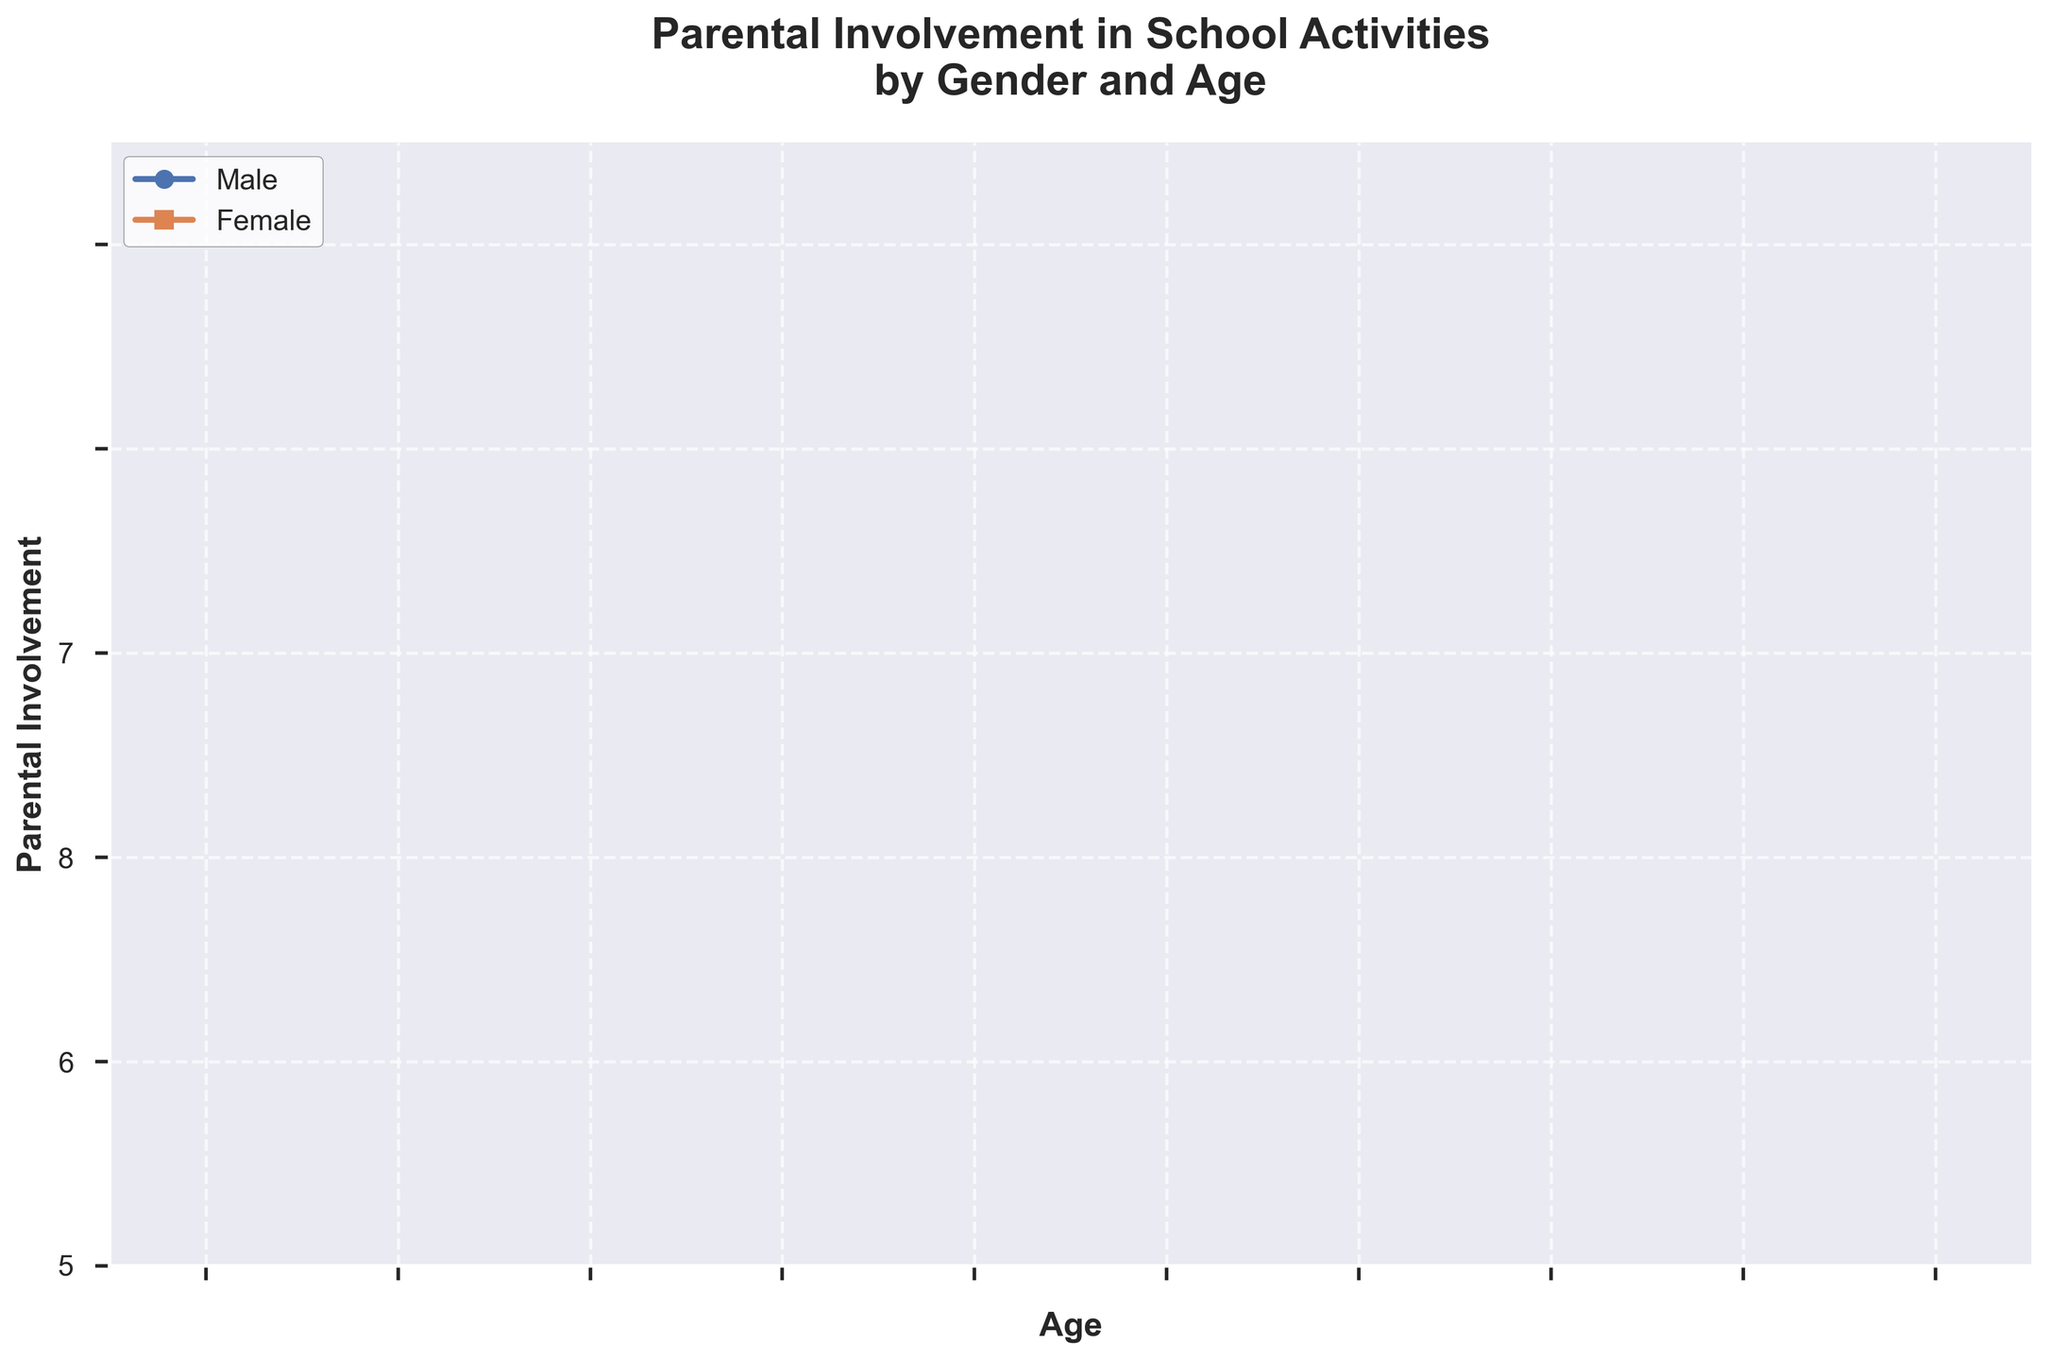What is the title of the plot? The title of the plot is displayed at the top of the figure in a larger, bold font, stating the focus of the data comparison.
Answer: Parental Involvement in School Activities by Gender and Age What age has the highest involvement for females? By looking at the stair plot for females (represented by a step line with square markers), identify the age with the maximum y-value.
Answer: 34 and 39 At what age do males have the minimum involvement? Examine the lowest point on the male stair plot (step line with circular markers) and note the corresponding age on the x-axis.
Answer: 34 On average, who has higher parental involvement, males or females? First, sum up the involvement values for both genders separately. Then divide each sum by the number of data points (10). Compare the two averages. For males: (5+4+6+5+3+4+5+4+6+4)/10=4.6. For females: (8+9+7+8+10+9+9+9+8+10)/10=8.7.
Answer: Females Which gender shows more fluctuations in involvement across ages? Examine the variability of the step lines for both genders on the plot. Fluctuations are indicated by the number and magnitude of changes in involvement values from one age to the next.
Answer: Females Does any age have equal involvement for both genders? Look for points on the plot where the stair steps for both genders align horizontally with the same involvement value.
Answer: No What is the difference in parental involvement between males and females at age 31? Read the involvement values for both genders at age 31 from the plot and calculate the difference. Female involvement at 31 is 9, and male involvement at 31 is 4. 9 - 4 = 5.
Answer: 5 What ages have the highest involvement for both genders combined? Determine the total involvement for each age by adding the male and female involvement values for each age. Find the ages with the highest combined involvement. Age 34 has combined involvement: 3 + 10 = 13. Age 39 has combined involvement: 4 + 10 = 14.
Answer: 39 